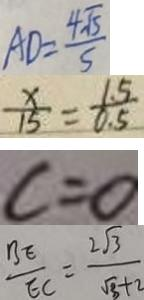Convert formula to latex. <formula><loc_0><loc_0><loc_500><loc_500>A D = \frac { 4 \sqrt { 5 } } { 5 } 
 \frac { x } { 1 5 } = \frac { 1 . 5 } { 0 . 5 } 
 c = 0 
 \frac { B E } { E C } = \frac { 2 \sqrt { 3 } } { \sqrt { 3 } + 2 }</formula> 